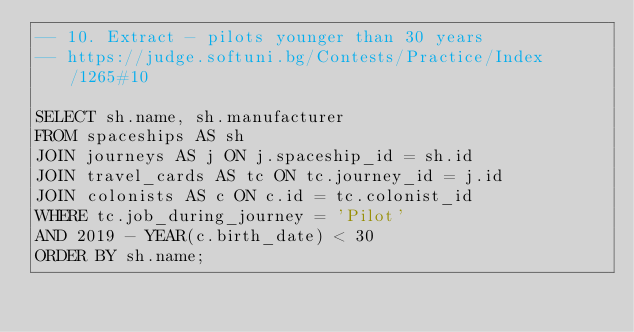Convert code to text. <code><loc_0><loc_0><loc_500><loc_500><_SQL_>-- 10. Extract - pilots younger than 30 years
-- https://judge.softuni.bg/Contests/Practice/Index/1265#10

SELECT sh.name, sh.manufacturer
FROM spaceships AS sh
JOIN journeys AS j ON j.spaceship_id = sh.id
JOIN travel_cards AS tc ON tc.journey_id = j.id
JOIN colonists AS c ON c.id = tc.colonist_id
WHERE tc.job_during_journey = 'Pilot'
AND 2019 - YEAR(c.birth_date) < 30
ORDER BY sh.name;</code> 